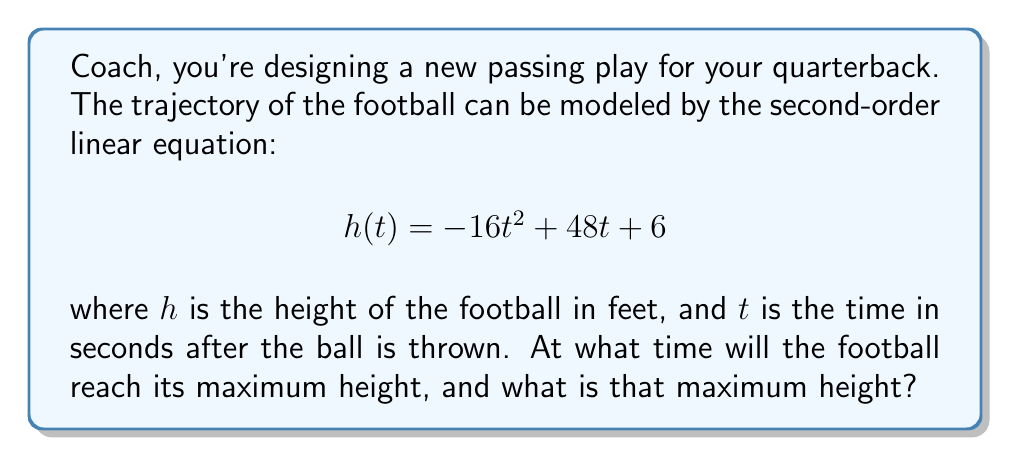Teach me how to tackle this problem. Alright, let's break this down like we're analyzing game film:

1) The equation $h(t) = -16t^2 + 48t + 6$ is a quadratic function, which represents the parabolic path of the football.

2) To find the maximum height, we need to find the vertex of this parabola. The vertex occurs at the axis of symmetry.

3) For a quadratic equation in the form $f(t) = at^2 + bt + c$, the t-coordinate of the vertex is given by $t = -\frac{b}{2a}$.

4) In our equation, $a = -16$, $b = 48$, and $c = 6$.

5) Plugging these values into the formula:

   $$t = -\frac{48}{2(-16)} = -\frac{48}{-32} = \frac{3}{2} = 1.5$$

6) So, the football reaches its maximum height at $t = 1.5$ seconds.

7) To find the maximum height, we plug this t-value back into our original equation:

   $$h(1.5) = -16(1.5)^2 + 48(1.5) + 6$$
   $$= -16(2.25) + 72 + 6$$
   $$= -36 + 72 + 6$$
   $$= 42$$

Therefore, the maximum height is 42 feet.
Answer: The football will reach its maximum height of 42 feet at 1.5 seconds after it's thrown. 